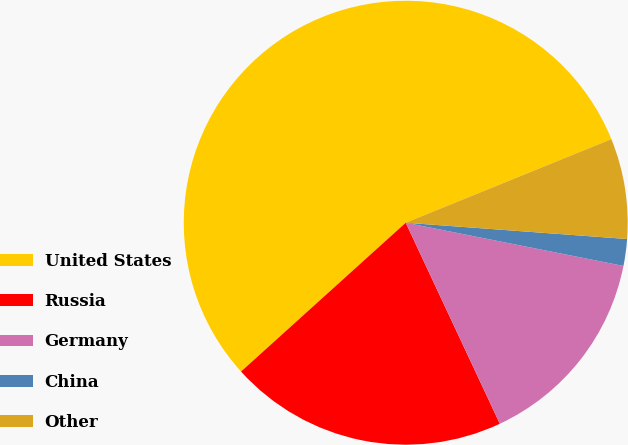Convert chart. <chart><loc_0><loc_0><loc_500><loc_500><pie_chart><fcel>United States<fcel>Russia<fcel>Germany<fcel>China<fcel>Other<nl><fcel>55.54%<fcel>20.27%<fcel>14.91%<fcel>1.95%<fcel>7.31%<nl></chart> 